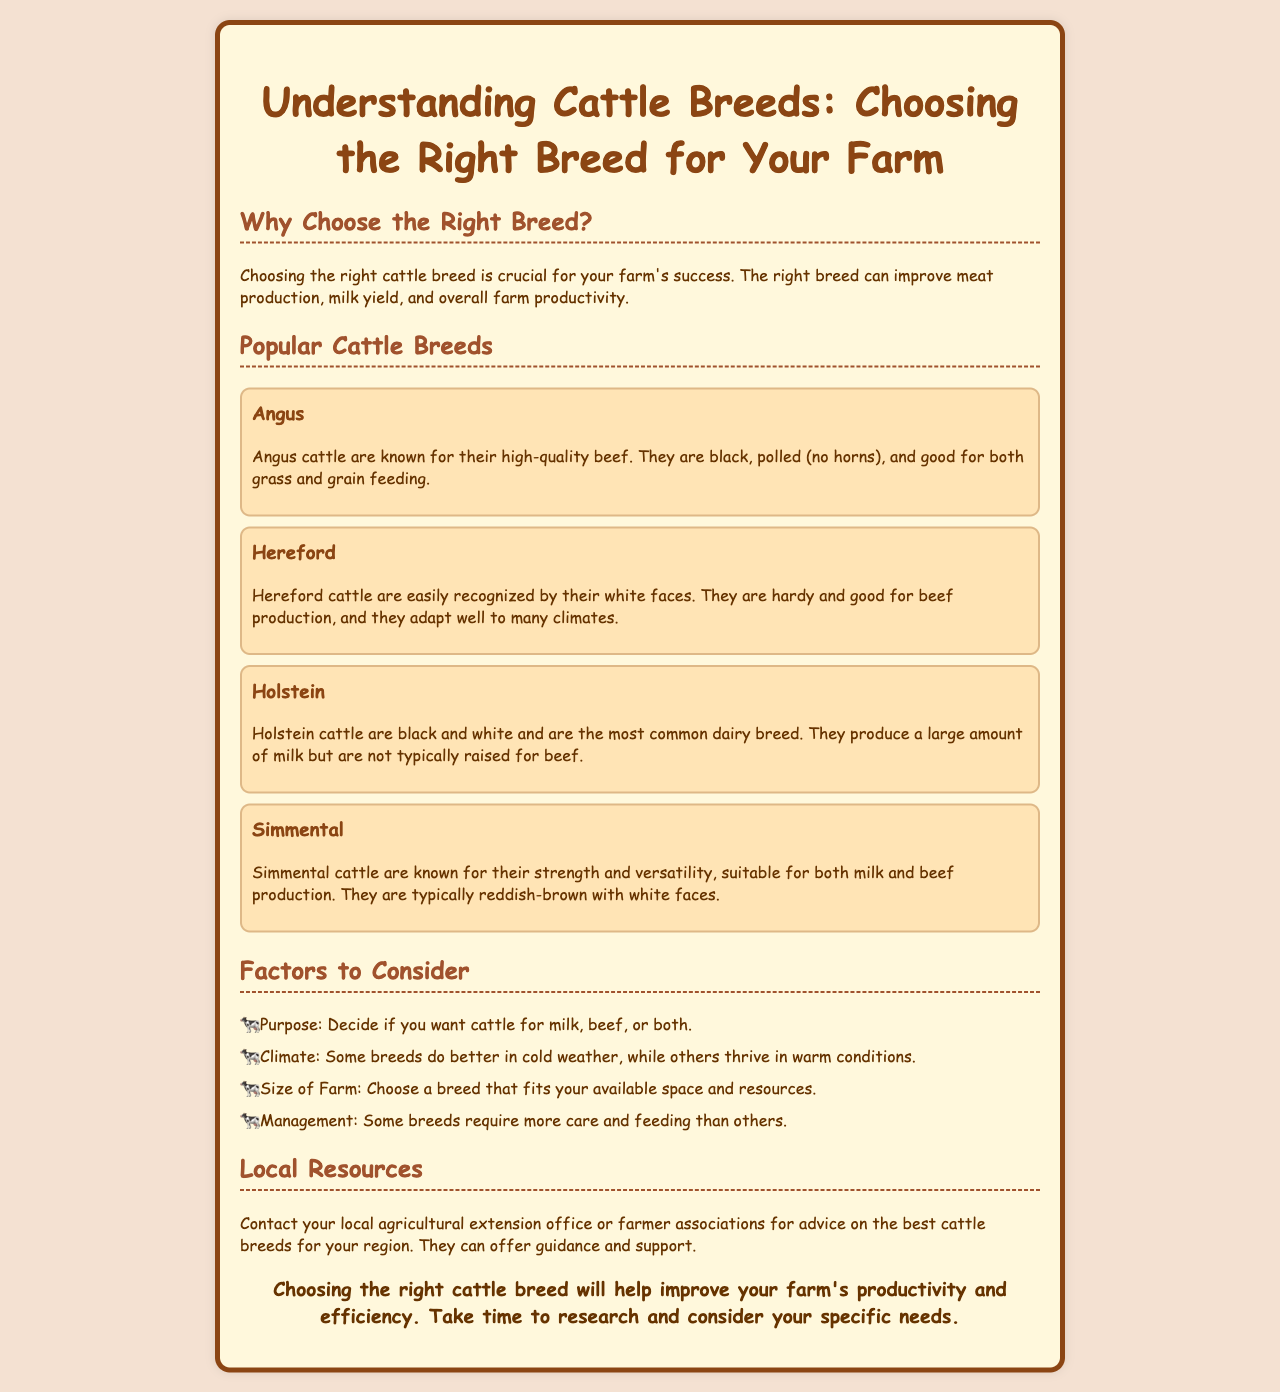What is the purpose of choosing the right breed? The document states that choosing the right cattle breed is crucial for your farm's success, improving meat production, milk yield, and overall productivity.
Answer: Improve productivity Which cattle breed is known for high-quality beef? The Angus breed is specifically mentioned for its high-quality beef.
Answer: Angus What color are Holstein cattle? The document describes Holstein cattle as black and white.
Answer: Black and white What breed is recognized by its white face? Hereford cattle are easily recognized by their white faces according to the document.
Answer: Hereford What two purposes can Simmental cattle serve? The document notes that Simmental cattle are suitable for both milk and beef production.
Answer: Milk and beef What should you consider if you have a small farm? The document suggests choosing a breed that fits your available space and resources for smaller farms.
Answer: Available space and resources Where can farmers get advice on cattle breeds? The document advises contacting local agricultural extension office or farmer associations for guidance.
Answer: Local agricultural extension office Why might some breeds require more care than others? The document implies that management of different breeds varies, affecting the level of care needed.
Answer: Management differences 